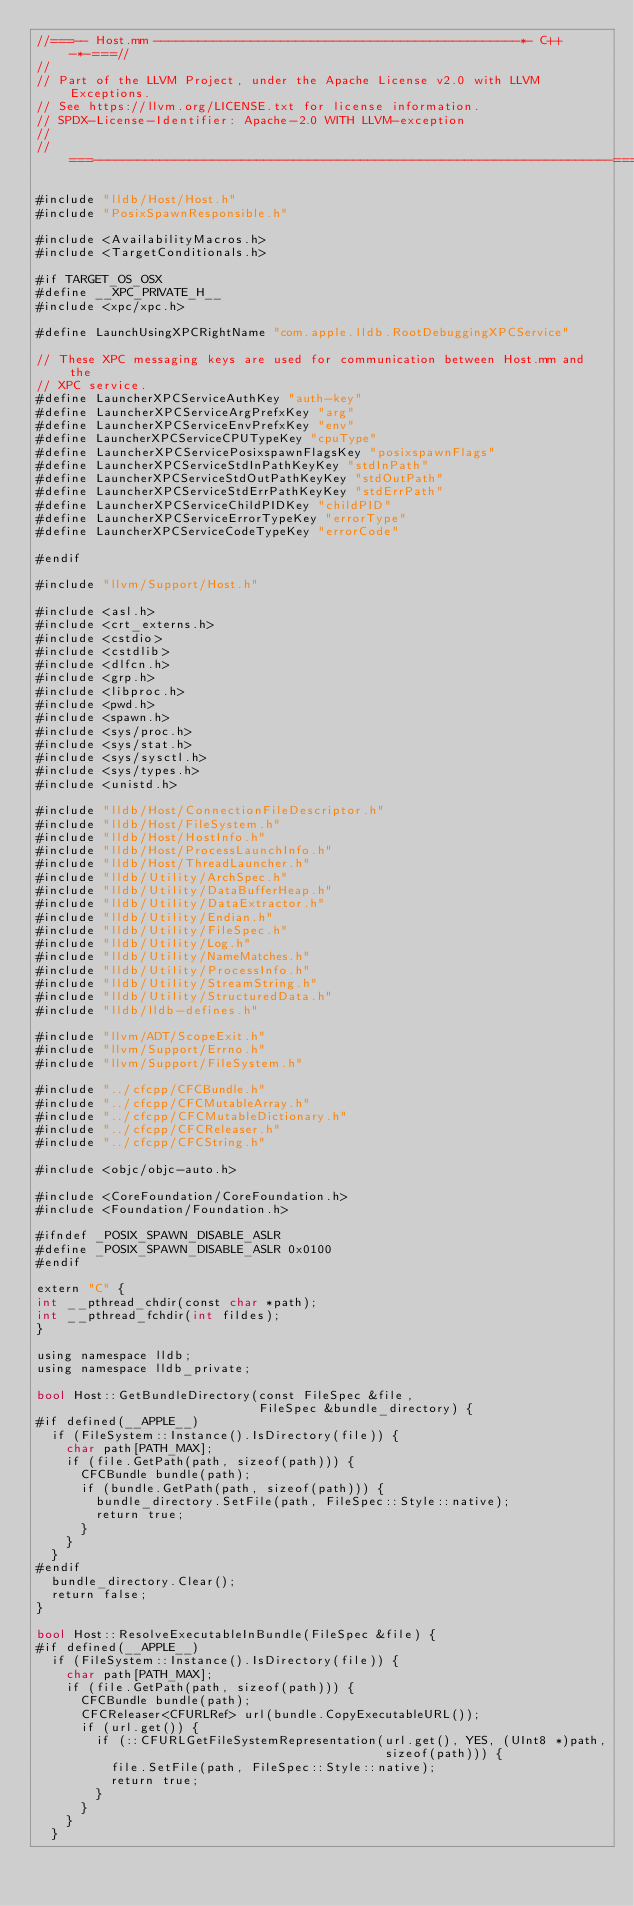Convert code to text. <code><loc_0><loc_0><loc_500><loc_500><_ObjectiveC_>//===-- Host.mm -------------------------------------------------*- C++ -*-===//
//
// Part of the LLVM Project, under the Apache License v2.0 with LLVM Exceptions.
// See https://llvm.org/LICENSE.txt for license information.
// SPDX-License-Identifier: Apache-2.0 WITH LLVM-exception
//
//===----------------------------------------------------------------------===//

#include "lldb/Host/Host.h"
#include "PosixSpawnResponsible.h"

#include <AvailabilityMacros.h>
#include <TargetConditionals.h>

#if TARGET_OS_OSX
#define __XPC_PRIVATE_H__
#include <xpc/xpc.h>

#define LaunchUsingXPCRightName "com.apple.lldb.RootDebuggingXPCService"

// These XPC messaging keys are used for communication between Host.mm and the
// XPC service.
#define LauncherXPCServiceAuthKey "auth-key"
#define LauncherXPCServiceArgPrefxKey "arg"
#define LauncherXPCServiceEnvPrefxKey "env"
#define LauncherXPCServiceCPUTypeKey "cpuType"
#define LauncherXPCServicePosixspawnFlagsKey "posixspawnFlags"
#define LauncherXPCServiceStdInPathKeyKey "stdInPath"
#define LauncherXPCServiceStdOutPathKeyKey "stdOutPath"
#define LauncherXPCServiceStdErrPathKeyKey "stdErrPath"
#define LauncherXPCServiceChildPIDKey "childPID"
#define LauncherXPCServiceErrorTypeKey "errorType"
#define LauncherXPCServiceCodeTypeKey "errorCode"

#endif

#include "llvm/Support/Host.h"

#include <asl.h>
#include <crt_externs.h>
#include <cstdio>
#include <cstdlib>
#include <dlfcn.h>
#include <grp.h>
#include <libproc.h>
#include <pwd.h>
#include <spawn.h>
#include <sys/proc.h>
#include <sys/stat.h>
#include <sys/sysctl.h>
#include <sys/types.h>
#include <unistd.h>

#include "lldb/Host/ConnectionFileDescriptor.h"
#include "lldb/Host/FileSystem.h"
#include "lldb/Host/HostInfo.h"
#include "lldb/Host/ProcessLaunchInfo.h"
#include "lldb/Host/ThreadLauncher.h"
#include "lldb/Utility/ArchSpec.h"
#include "lldb/Utility/DataBufferHeap.h"
#include "lldb/Utility/DataExtractor.h"
#include "lldb/Utility/Endian.h"
#include "lldb/Utility/FileSpec.h"
#include "lldb/Utility/Log.h"
#include "lldb/Utility/NameMatches.h"
#include "lldb/Utility/ProcessInfo.h"
#include "lldb/Utility/StreamString.h"
#include "lldb/Utility/StructuredData.h"
#include "lldb/lldb-defines.h"

#include "llvm/ADT/ScopeExit.h"
#include "llvm/Support/Errno.h"
#include "llvm/Support/FileSystem.h"

#include "../cfcpp/CFCBundle.h"
#include "../cfcpp/CFCMutableArray.h"
#include "../cfcpp/CFCMutableDictionary.h"
#include "../cfcpp/CFCReleaser.h"
#include "../cfcpp/CFCString.h"

#include <objc/objc-auto.h>

#include <CoreFoundation/CoreFoundation.h>
#include <Foundation/Foundation.h>

#ifndef _POSIX_SPAWN_DISABLE_ASLR
#define _POSIX_SPAWN_DISABLE_ASLR 0x0100
#endif

extern "C" {
int __pthread_chdir(const char *path);
int __pthread_fchdir(int fildes);
}

using namespace lldb;
using namespace lldb_private;

bool Host::GetBundleDirectory(const FileSpec &file,
                              FileSpec &bundle_directory) {
#if defined(__APPLE__)
  if (FileSystem::Instance().IsDirectory(file)) {
    char path[PATH_MAX];
    if (file.GetPath(path, sizeof(path))) {
      CFCBundle bundle(path);
      if (bundle.GetPath(path, sizeof(path))) {
        bundle_directory.SetFile(path, FileSpec::Style::native);
        return true;
      }
    }
  }
#endif
  bundle_directory.Clear();
  return false;
}

bool Host::ResolveExecutableInBundle(FileSpec &file) {
#if defined(__APPLE__)
  if (FileSystem::Instance().IsDirectory(file)) {
    char path[PATH_MAX];
    if (file.GetPath(path, sizeof(path))) {
      CFCBundle bundle(path);
      CFCReleaser<CFURLRef> url(bundle.CopyExecutableURL());
      if (url.get()) {
        if (::CFURLGetFileSystemRepresentation(url.get(), YES, (UInt8 *)path,
                                               sizeof(path))) {
          file.SetFile(path, FileSpec::Style::native);
          return true;
        }
      }
    }
  }</code> 